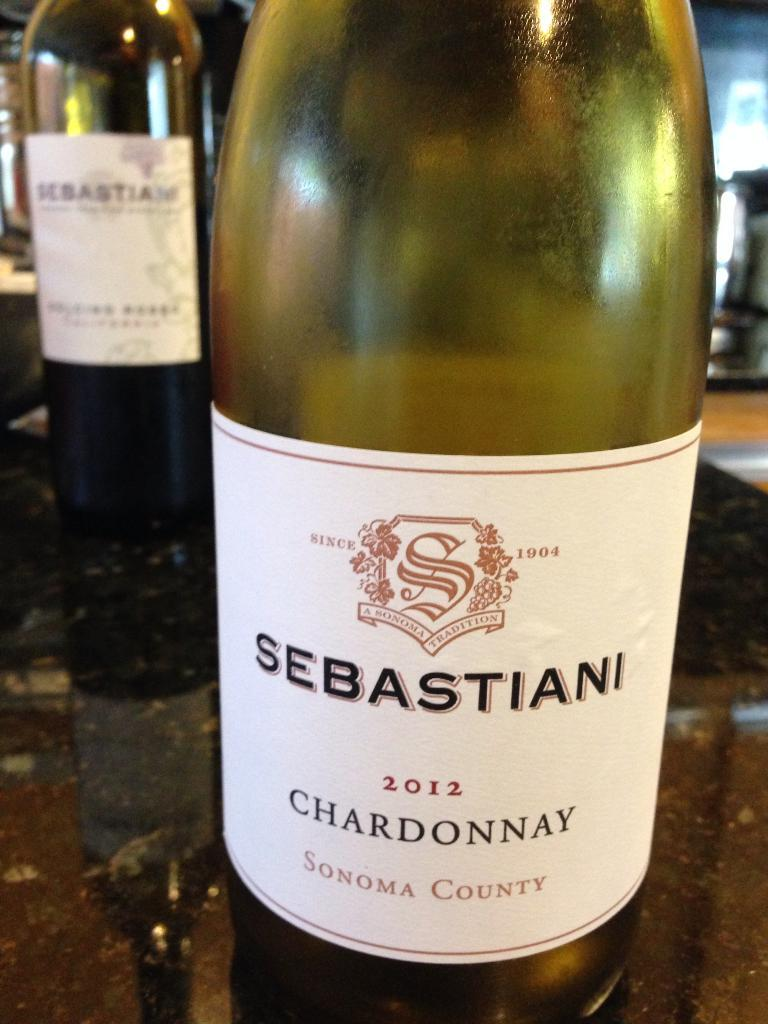<image>
Offer a succinct explanation of the picture presented. the name Sebastian that is on a bottle 